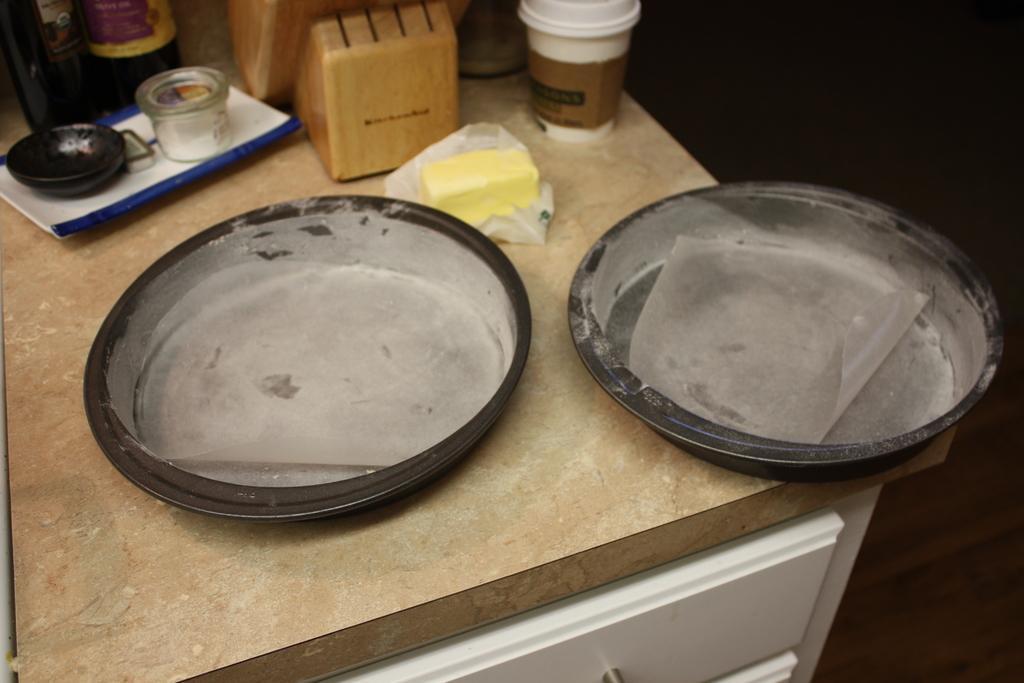Could you give a brief overview of what you see in this image? In this image, we can see a black cake pans is dusting with powder. Here we can see a butter paper in the pans. Top of the image, we can see few objects, butter, some items. These items are placed on the table. At the bottom, we can see a cupboards. 